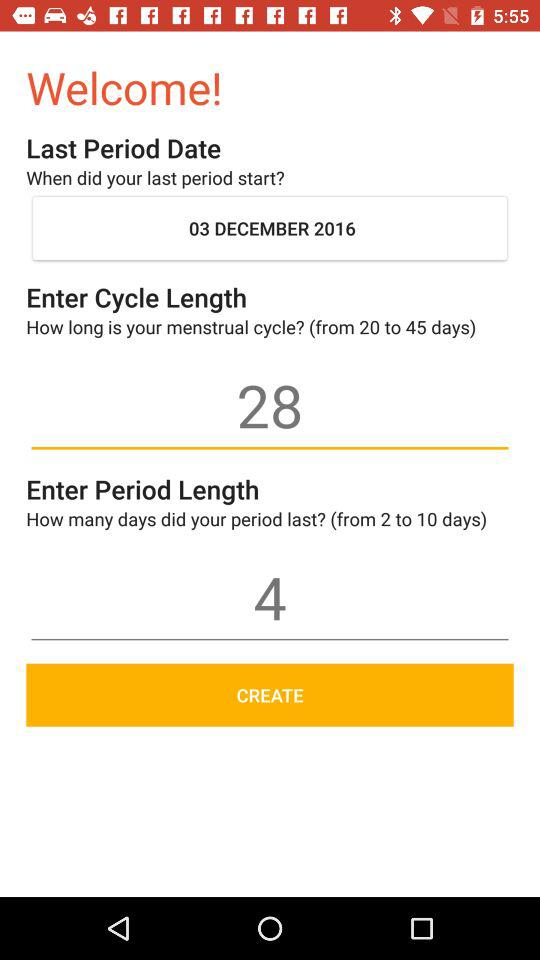How many more days is the cycle length than the period length?
Answer the question using a single word or phrase. 24 